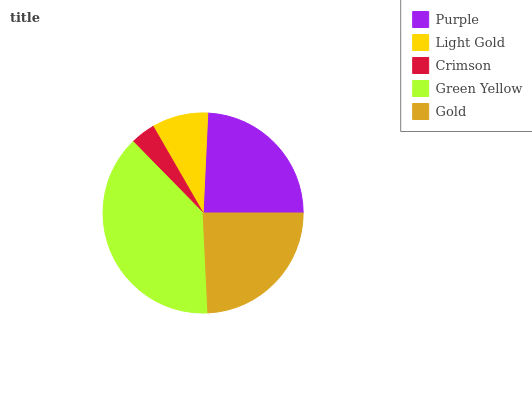Is Crimson the minimum?
Answer yes or no. Yes. Is Green Yellow the maximum?
Answer yes or no. Yes. Is Light Gold the minimum?
Answer yes or no. No. Is Light Gold the maximum?
Answer yes or no. No. Is Purple greater than Light Gold?
Answer yes or no. Yes. Is Light Gold less than Purple?
Answer yes or no. Yes. Is Light Gold greater than Purple?
Answer yes or no. No. Is Purple less than Light Gold?
Answer yes or no. No. Is Gold the high median?
Answer yes or no. Yes. Is Gold the low median?
Answer yes or no. Yes. Is Purple the high median?
Answer yes or no. No. Is Green Yellow the low median?
Answer yes or no. No. 